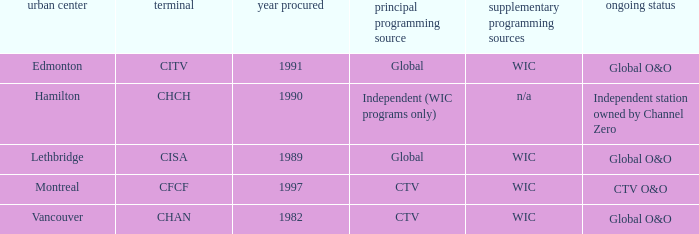How many channels were gained in 1997 1.0. 